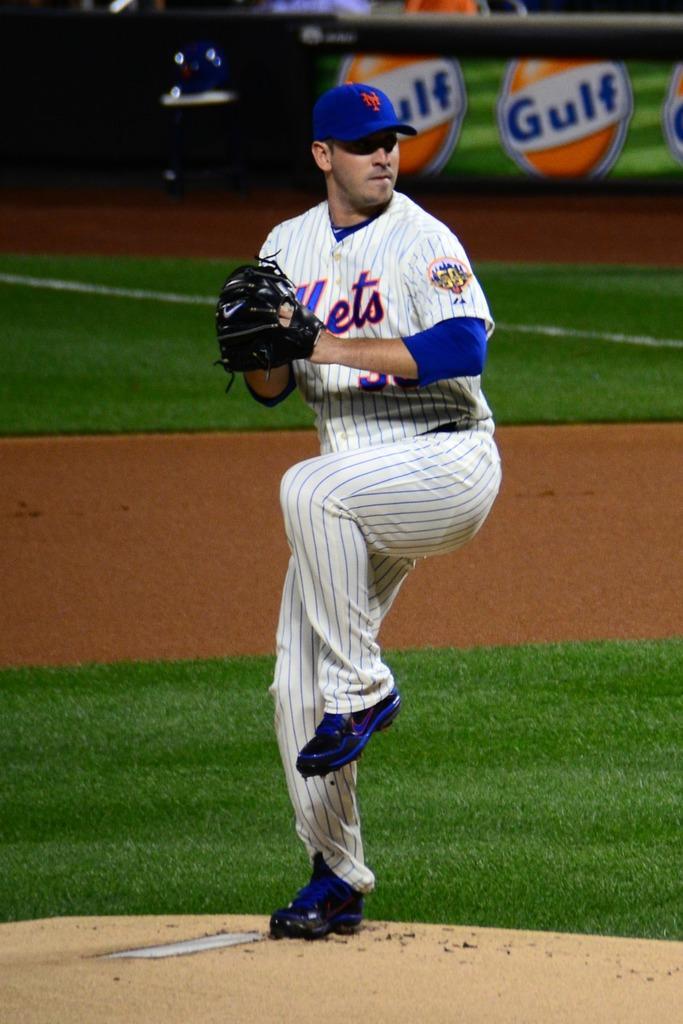In one or two sentences, can you explain what this image depicts? In the center of the image there is a player standing on the ground. In the background we can see grass and advertisement. 